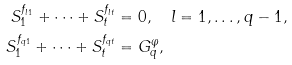<formula> <loc_0><loc_0><loc_500><loc_500>S _ { 1 } ^ { f _ { l 1 } } + \dots + S _ { t } ^ { f _ { l t } } & = 0 , \quad l = 1 , \dots , q - 1 , \\ S _ { 1 } ^ { f _ { q 1 } } + \dots + S _ { t } ^ { f _ { q t } } & = G _ { q } ^ { \varphi } ,</formula> 